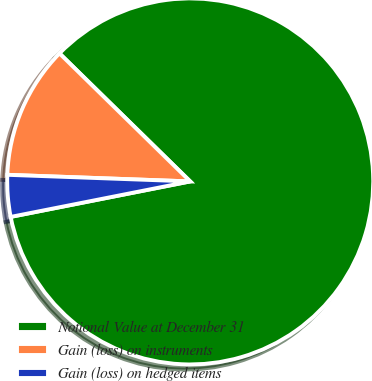Convert chart to OTSL. <chart><loc_0><loc_0><loc_500><loc_500><pie_chart><fcel>Notional Value at December 31<fcel>Gain (loss) on instruments<fcel>Gain (loss) on hedged items<nl><fcel>84.56%<fcel>11.76%<fcel>3.68%<nl></chart> 